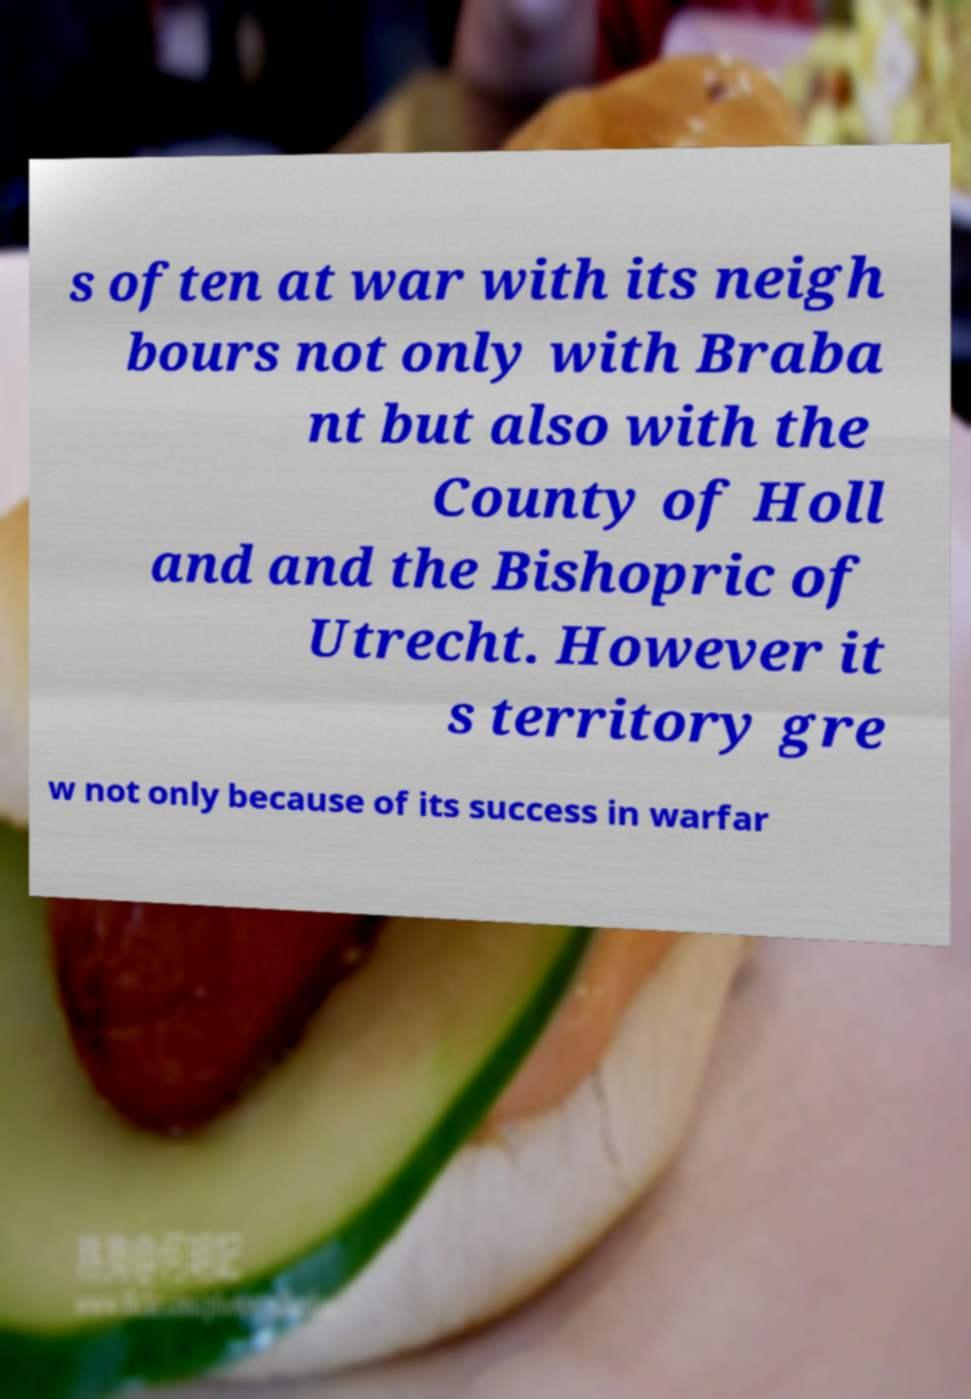Could you extract and type out the text from this image? s often at war with its neigh bours not only with Braba nt but also with the County of Holl and and the Bishopric of Utrecht. However it s territory gre w not only because of its success in warfar 